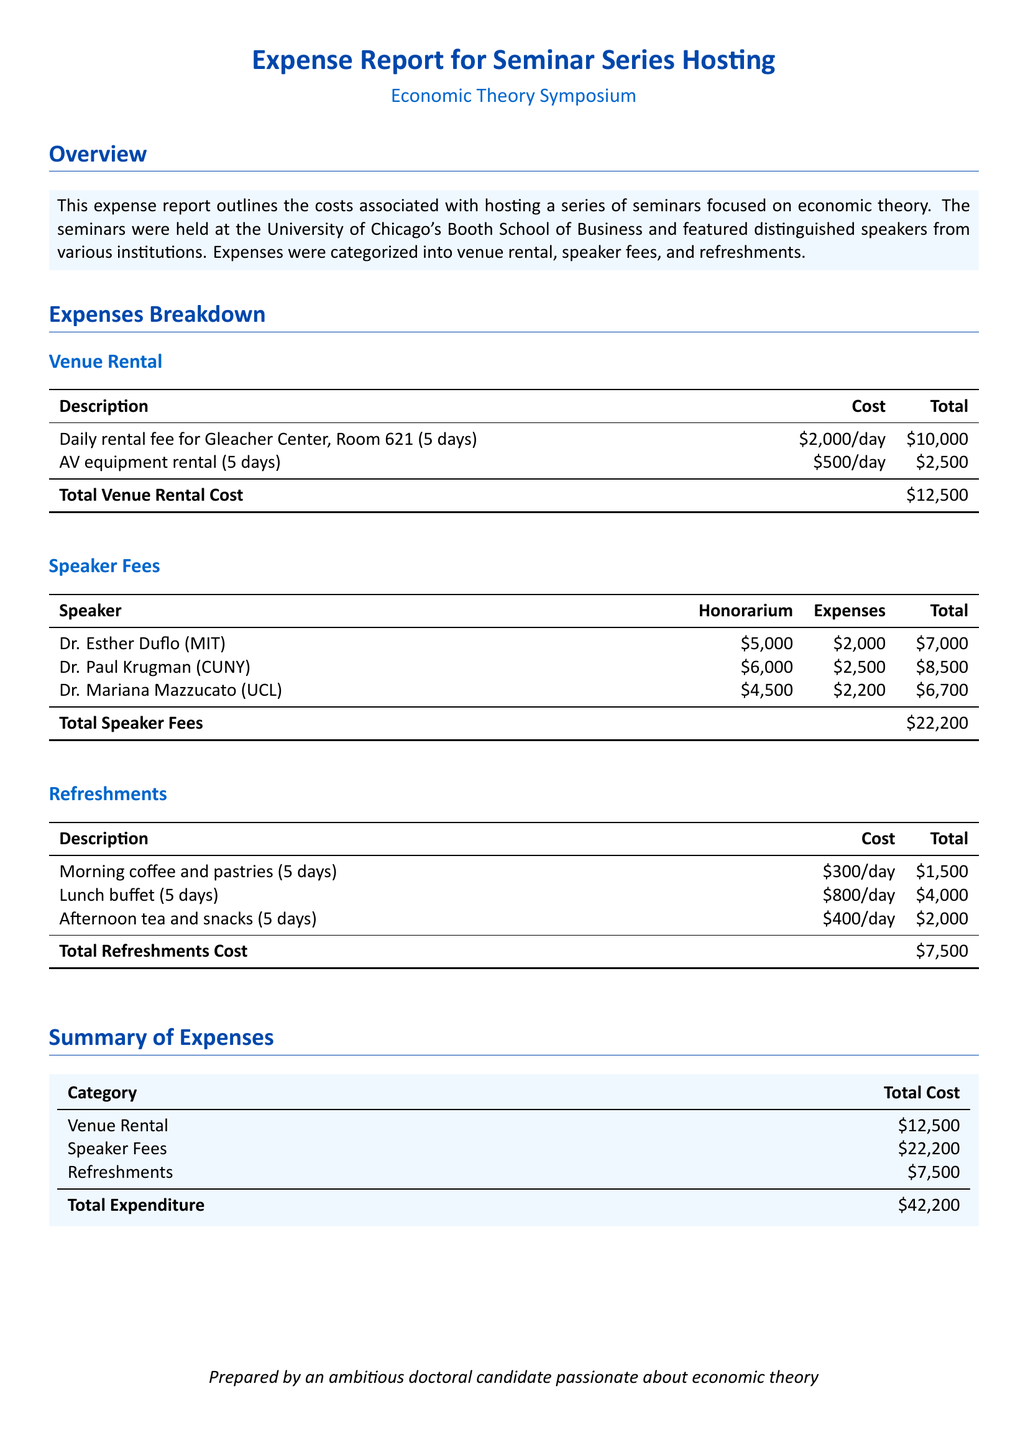What is the total cost of venue rental? The total cost is listed in the "Venue Rental" section, which amounts to $12,500.
Answer: $12,500 Who is the speaker with the highest honorarium? By examining the "Speaker Fees" section, Dr. Paul Krugman has the highest honorarium of $6,000.
Answer: Dr. Paul Krugman What is the total expenditure for the seminar series? The total expenditure is found in the "Summary of Expenses" section, adding up to $42,200.
Answer: $42,200 How much was spent on refreshments in total? The "Refreshments" section shows the total cost specifically listed as $7,500.
Answer: $7,500 What was the daily rental fee for the venue? The daily rental fee for the Gleacher Center is stated as $2,000 per day.
Answer: $2,000 How many days did the seminars take place? The expenses for both venue rental and refreshments indicate these services were needed for 5 days.
Answer: 5 days What are the total expenses incurred by Dr. Esther Duflo? Dr. Esther Duflo's total expenses include her honorarium and additional expenses totaling $7,000, as detailed in the "Speaker Fees" section.
Answer: $7,000 What type of refreshments were provided throughout the seminars? The types of refreshments include morning coffee, lunch buffet, and afternoon tea as detailed in the "Refreshments" section.
Answer: Coffee, lunch buffet, tea What is the cost of AV equipment rental for the entire seminar? The "Venue Rental" section states the total cost for AV equipment rental for 5 days is $2,500.
Answer: $2,500 